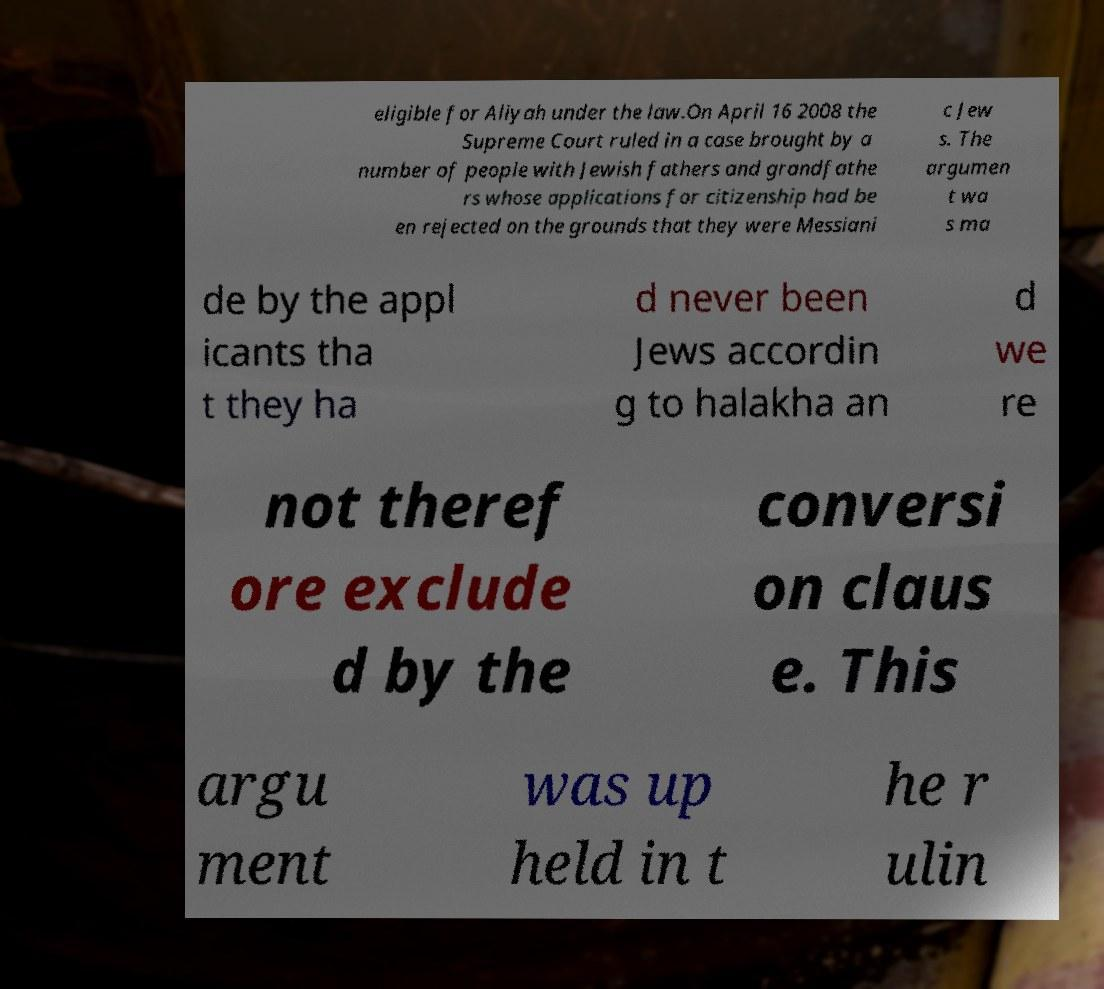I need the written content from this picture converted into text. Can you do that? eligible for Aliyah under the law.On April 16 2008 the Supreme Court ruled in a case brought by a number of people with Jewish fathers and grandfathe rs whose applications for citizenship had be en rejected on the grounds that they were Messiani c Jew s. The argumen t wa s ma de by the appl icants tha t they ha d never been Jews accordin g to halakha an d we re not theref ore exclude d by the conversi on claus e. This argu ment was up held in t he r ulin 